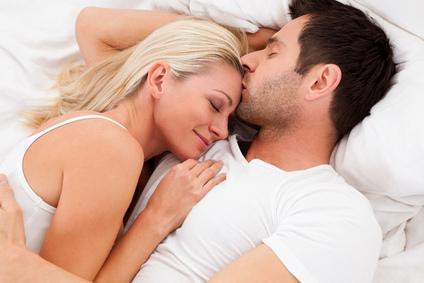How many people are visible?
Give a very brief answer. 2. How many toilets are there?
Give a very brief answer. 0. 